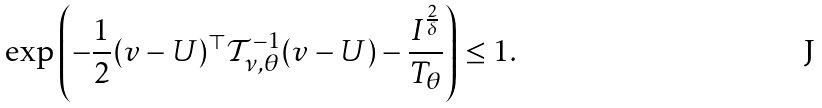<formula> <loc_0><loc_0><loc_500><loc_500>\exp \left ( - \frac { 1 } { 2 } ( v - U ) ^ { \top } \mathcal { T } _ { \nu , \theta } ^ { - 1 } ( v - U ) - \frac { I ^ { \frac { 2 } { \delta } } } { T _ { \theta } } \right ) \leq 1 .</formula> 